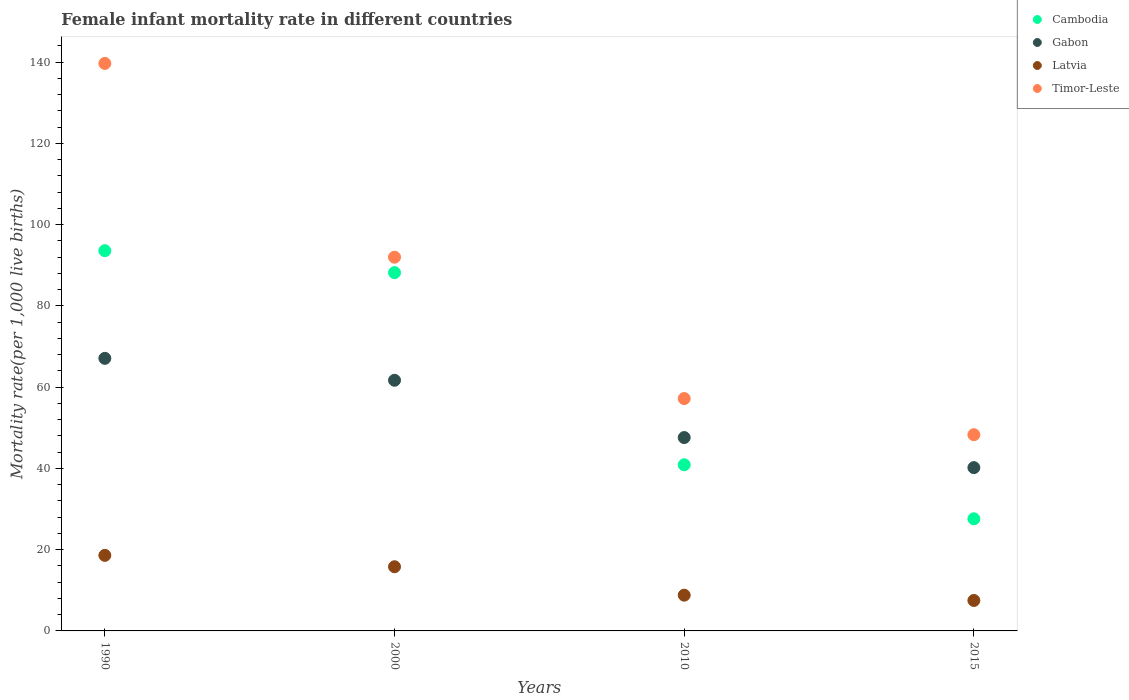How many different coloured dotlines are there?
Your answer should be compact. 4. Is the number of dotlines equal to the number of legend labels?
Offer a very short reply. Yes. What is the female infant mortality rate in Gabon in 1990?
Provide a succinct answer. 67.1. Across all years, what is the maximum female infant mortality rate in Gabon?
Provide a succinct answer. 67.1. Across all years, what is the minimum female infant mortality rate in Timor-Leste?
Offer a very short reply. 48.3. In which year was the female infant mortality rate in Gabon minimum?
Offer a terse response. 2015. What is the total female infant mortality rate in Gabon in the graph?
Make the answer very short. 216.6. What is the difference between the female infant mortality rate in Timor-Leste in 1990 and that in 2015?
Give a very brief answer. 91.4. What is the difference between the female infant mortality rate in Gabon in 2015 and the female infant mortality rate in Timor-Leste in 2010?
Your answer should be very brief. -17. What is the average female infant mortality rate in Gabon per year?
Offer a terse response. 54.15. In the year 2000, what is the difference between the female infant mortality rate in Gabon and female infant mortality rate in Timor-Leste?
Make the answer very short. -30.3. What is the ratio of the female infant mortality rate in Timor-Leste in 2010 to that in 2015?
Keep it short and to the point. 1.18. Is the female infant mortality rate in Gabon in 1990 less than that in 2015?
Offer a terse response. No. Is the difference between the female infant mortality rate in Gabon in 1990 and 2015 greater than the difference between the female infant mortality rate in Timor-Leste in 1990 and 2015?
Keep it short and to the point. No. What is the difference between the highest and the second highest female infant mortality rate in Gabon?
Offer a terse response. 5.4. What is the difference between the highest and the lowest female infant mortality rate in Timor-Leste?
Your answer should be very brief. 91.4. In how many years, is the female infant mortality rate in Cambodia greater than the average female infant mortality rate in Cambodia taken over all years?
Offer a very short reply. 2. Is it the case that in every year, the sum of the female infant mortality rate in Cambodia and female infant mortality rate in Latvia  is greater than the female infant mortality rate in Timor-Leste?
Ensure brevity in your answer.  No. Is the female infant mortality rate in Timor-Leste strictly greater than the female infant mortality rate in Cambodia over the years?
Offer a terse response. Yes. Is the female infant mortality rate in Gabon strictly less than the female infant mortality rate in Timor-Leste over the years?
Offer a terse response. Yes. What is the difference between two consecutive major ticks on the Y-axis?
Make the answer very short. 20. Does the graph contain any zero values?
Your answer should be very brief. No. Does the graph contain grids?
Your answer should be very brief. No. Where does the legend appear in the graph?
Offer a terse response. Top right. What is the title of the graph?
Provide a succinct answer. Female infant mortality rate in different countries. What is the label or title of the Y-axis?
Give a very brief answer. Mortality rate(per 1,0 live births). What is the Mortality rate(per 1,000 live births) of Cambodia in 1990?
Keep it short and to the point. 93.6. What is the Mortality rate(per 1,000 live births) in Gabon in 1990?
Keep it short and to the point. 67.1. What is the Mortality rate(per 1,000 live births) in Timor-Leste in 1990?
Give a very brief answer. 139.7. What is the Mortality rate(per 1,000 live births) of Cambodia in 2000?
Give a very brief answer. 88.2. What is the Mortality rate(per 1,000 live births) in Gabon in 2000?
Your answer should be very brief. 61.7. What is the Mortality rate(per 1,000 live births) in Timor-Leste in 2000?
Provide a succinct answer. 92. What is the Mortality rate(per 1,000 live births) of Cambodia in 2010?
Give a very brief answer. 40.9. What is the Mortality rate(per 1,000 live births) of Gabon in 2010?
Your response must be concise. 47.6. What is the Mortality rate(per 1,000 live births) of Latvia in 2010?
Your answer should be very brief. 8.8. What is the Mortality rate(per 1,000 live births) in Timor-Leste in 2010?
Offer a terse response. 57.2. What is the Mortality rate(per 1,000 live births) of Cambodia in 2015?
Offer a terse response. 27.6. What is the Mortality rate(per 1,000 live births) of Gabon in 2015?
Provide a succinct answer. 40.2. What is the Mortality rate(per 1,000 live births) of Latvia in 2015?
Give a very brief answer. 7.5. What is the Mortality rate(per 1,000 live births) of Timor-Leste in 2015?
Provide a succinct answer. 48.3. Across all years, what is the maximum Mortality rate(per 1,000 live births) in Cambodia?
Your response must be concise. 93.6. Across all years, what is the maximum Mortality rate(per 1,000 live births) in Gabon?
Offer a terse response. 67.1. Across all years, what is the maximum Mortality rate(per 1,000 live births) in Timor-Leste?
Your response must be concise. 139.7. Across all years, what is the minimum Mortality rate(per 1,000 live births) in Cambodia?
Keep it short and to the point. 27.6. Across all years, what is the minimum Mortality rate(per 1,000 live births) of Gabon?
Provide a short and direct response. 40.2. Across all years, what is the minimum Mortality rate(per 1,000 live births) in Latvia?
Your response must be concise. 7.5. Across all years, what is the minimum Mortality rate(per 1,000 live births) of Timor-Leste?
Your answer should be very brief. 48.3. What is the total Mortality rate(per 1,000 live births) in Cambodia in the graph?
Your response must be concise. 250.3. What is the total Mortality rate(per 1,000 live births) in Gabon in the graph?
Your answer should be very brief. 216.6. What is the total Mortality rate(per 1,000 live births) in Latvia in the graph?
Make the answer very short. 50.7. What is the total Mortality rate(per 1,000 live births) in Timor-Leste in the graph?
Offer a very short reply. 337.2. What is the difference between the Mortality rate(per 1,000 live births) of Gabon in 1990 and that in 2000?
Your response must be concise. 5.4. What is the difference between the Mortality rate(per 1,000 live births) in Latvia in 1990 and that in 2000?
Offer a terse response. 2.8. What is the difference between the Mortality rate(per 1,000 live births) in Timor-Leste in 1990 and that in 2000?
Make the answer very short. 47.7. What is the difference between the Mortality rate(per 1,000 live births) in Cambodia in 1990 and that in 2010?
Offer a very short reply. 52.7. What is the difference between the Mortality rate(per 1,000 live births) in Gabon in 1990 and that in 2010?
Make the answer very short. 19.5. What is the difference between the Mortality rate(per 1,000 live births) of Timor-Leste in 1990 and that in 2010?
Your response must be concise. 82.5. What is the difference between the Mortality rate(per 1,000 live births) in Cambodia in 1990 and that in 2015?
Offer a terse response. 66. What is the difference between the Mortality rate(per 1,000 live births) of Gabon in 1990 and that in 2015?
Your answer should be compact. 26.9. What is the difference between the Mortality rate(per 1,000 live births) in Timor-Leste in 1990 and that in 2015?
Make the answer very short. 91.4. What is the difference between the Mortality rate(per 1,000 live births) of Cambodia in 2000 and that in 2010?
Your answer should be very brief. 47.3. What is the difference between the Mortality rate(per 1,000 live births) of Gabon in 2000 and that in 2010?
Ensure brevity in your answer.  14.1. What is the difference between the Mortality rate(per 1,000 live births) in Latvia in 2000 and that in 2010?
Provide a succinct answer. 7. What is the difference between the Mortality rate(per 1,000 live births) in Timor-Leste in 2000 and that in 2010?
Your answer should be very brief. 34.8. What is the difference between the Mortality rate(per 1,000 live births) of Cambodia in 2000 and that in 2015?
Offer a terse response. 60.6. What is the difference between the Mortality rate(per 1,000 live births) of Timor-Leste in 2000 and that in 2015?
Provide a short and direct response. 43.7. What is the difference between the Mortality rate(per 1,000 live births) in Gabon in 2010 and that in 2015?
Your answer should be very brief. 7.4. What is the difference between the Mortality rate(per 1,000 live births) of Timor-Leste in 2010 and that in 2015?
Offer a very short reply. 8.9. What is the difference between the Mortality rate(per 1,000 live births) in Cambodia in 1990 and the Mortality rate(per 1,000 live births) in Gabon in 2000?
Make the answer very short. 31.9. What is the difference between the Mortality rate(per 1,000 live births) of Cambodia in 1990 and the Mortality rate(per 1,000 live births) of Latvia in 2000?
Ensure brevity in your answer.  77.8. What is the difference between the Mortality rate(per 1,000 live births) of Gabon in 1990 and the Mortality rate(per 1,000 live births) of Latvia in 2000?
Provide a succinct answer. 51.3. What is the difference between the Mortality rate(per 1,000 live births) of Gabon in 1990 and the Mortality rate(per 1,000 live births) of Timor-Leste in 2000?
Offer a terse response. -24.9. What is the difference between the Mortality rate(per 1,000 live births) of Latvia in 1990 and the Mortality rate(per 1,000 live births) of Timor-Leste in 2000?
Provide a succinct answer. -73.4. What is the difference between the Mortality rate(per 1,000 live births) of Cambodia in 1990 and the Mortality rate(per 1,000 live births) of Gabon in 2010?
Give a very brief answer. 46. What is the difference between the Mortality rate(per 1,000 live births) of Cambodia in 1990 and the Mortality rate(per 1,000 live births) of Latvia in 2010?
Offer a very short reply. 84.8. What is the difference between the Mortality rate(per 1,000 live births) in Cambodia in 1990 and the Mortality rate(per 1,000 live births) in Timor-Leste in 2010?
Ensure brevity in your answer.  36.4. What is the difference between the Mortality rate(per 1,000 live births) in Gabon in 1990 and the Mortality rate(per 1,000 live births) in Latvia in 2010?
Make the answer very short. 58.3. What is the difference between the Mortality rate(per 1,000 live births) of Gabon in 1990 and the Mortality rate(per 1,000 live births) of Timor-Leste in 2010?
Keep it short and to the point. 9.9. What is the difference between the Mortality rate(per 1,000 live births) of Latvia in 1990 and the Mortality rate(per 1,000 live births) of Timor-Leste in 2010?
Ensure brevity in your answer.  -38.6. What is the difference between the Mortality rate(per 1,000 live births) of Cambodia in 1990 and the Mortality rate(per 1,000 live births) of Gabon in 2015?
Make the answer very short. 53.4. What is the difference between the Mortality rate(per 1,000 live births) in Cambodia in 1990 and the Mortality rate(per 1,000 live births) in Latvia in 2015?
Offer a very short reply. 86.1. What is the difference between the Mortality rate(per 1,000 live births) of Cambodia in 1990 and the Mortality rate(per 1,000 live births) of Timor-Leste in 2015?
Offer a terse response. 45.3. What is the difference between the Mortality rate(per 1,000 live births) in Gabon in 1990 and the Mortality rate(per 1,000 live births) in Latvia in 2015?
Make the answer very short. 59.6. What is the difference between the Mortality rate(per 1,000 live births) of Gabon in 1990 and the Mortality rate(per 1,000 live births) of Timor-Leste in 2015?
Offer a terse response. 18.8. What is the difference between the Mortality rate(per 1,000 live births) of Latvia in 1990 and the Mortality rate(per 1,000 live births) of Timor-Leste in 2015?
Offer a terse response. -29.7. What is the difference between the Mortality rate(per 1,000 live births) of Cambodia in 2000 and the Mortality rate(per 1,000 live births) of Gabon in 2010?
Keep it short and to the point. 40.6. What is the difference between the Mortality rate(per 1,000 live births) of Cambodia in 2000 and the Mortality rate(per 1,000 live births) of Latvia in 2010?
Provide a succinct answer. 79.4. What is the difference between the Mortality rate(per 1,000 live births) of Cambodia in 2000 and the Mortality rate(per 1,000 live births) of Timor-Leste in 2010?
Your answer should be compact. 31. What is the difference between the Mortality rate(per 1,000 live births) of Gabon in 2000 and the Mortality rate(per 1,000 live births) of Latvia in 2010?
Ensure brevity in your answer.  52.9. What is the difference between the Mortality rate(per 1,000 live births) of Latvia in 2000 and the Mortality rate(per 1,000 live births) of Timor-Leste in 2010?
Give a very brief answer. -41.4. What is the difference between the Mortality rate(per 1,000 live births) of Cambodia in 2000 and the Mortality rate(per 1,000 live births) of Latvia in 2015?
Your response must be concise. 80.7. What is the difference between the Mortality rate(per 1,000 live births) of Cambodia in 2000 and the Mortality rate(per 1,000 live births) of Timor-Leste in 2015?
Ensure brevity in your answer.  39.9. What is the difference between the Mortality rate(per 1,000 live births) of Gabon in 2000 and the Mortality rate(per 1,000 live births) of Latvia in 2015?
Give a very brief answer. 54.2. What is the difference between the Mortality rate(per 1,000 live births) of Latvia in 2000 and the Mortality rate(per 1,000 live births) of Timor-Leste in 2015?
Your response must be concise. -32.5. What is the difference between the Mortality rate(per 1,000 live births) of Cambodia in 2010 and the Mortality rate(per 1,000 live births) of Latvia in 2015?
Your answer should be very brief. 33.4. What is the difference between the Mortality rate(per 1,000 live births) in Gabon in 2010 and the Mortality rate(per 1,000 live births) in Latvia in 2015?
Your answer should be compact. 40.1. What is the difference between the Mortality rate(per 1,000 live births) in Gabon in 2010 and the Mortality rate(per 1,000 live births) in Timor-Leste in 2015?
Provide a succinct answer. -0.7. What is the difference between the Mortality rate(per 1,000 live births) in Latvia in 2010 and the Mortality rate(per 1,000 live births) in Timor-Leste in 2015?
Make the answer very short. -39.5. What is the average Mortality rate(per 1,000 live births) in Cambodia per year?
Your response must be concise. 62.58. What is the average Mortality rate(per 1,000 live births) in Gabon per year?
Your answer should be compact. 54.15. What is the average Mortality rate(per 1,000 live births) in Latvia per year?
Your answer should be compact. 12.68. What is the average Mortality rate(per 1,000 live births) in Timor-Leste per year?
Your answer should be compact. 84.3. In the year 1990, what is the difference between the Mortality rate(per 1,000 live births) in Cambodia and Mortality rate(per 1,000 live births) in Gabon?
Your answer should be compact. 26.5. In the year 1990, what is the difference between the Mortality rate(per 1,000 live births) of Cambodia and Mortality rate(per 1,000 live births) of Latvia?
Make the answer very short. 75. In the year 1990, what is the difference between the Mortality rate(per 1,000 live births) in Cambodia and Mortality rate(per 1,000 live births) in Timor-Leste?
Ensure brevity in your answer.  -46.1. In the year 1990, what is the difference between the Mortality rate(per 1,000 live births) of Gabon and Mortality rate(per 1,000 live births) of Latvia?
Make the answer very short. 48.5. In the year 1990, what is the difference between the Mortality rate(per 1,000 live births) in Gabon and Mortality rate(per 1,000 live births) in Timor-Leste?
Your response must be concise. -72.6. In the year 1990, what is the difference between the Mortality rate(per 1,000 live births) in Latvia and Mortality rate(per 1,000 live births) in Timor-Leste?
Offer a terse response. -121.1. In the year 2000, what is the difference between the Mortality rate(per 1,000 live births) of Cambodia and Mortality rate(per 1,000 live births) of Gabon?
Ensure brevity in your answer.  26.5. In the year 2000, what is the difference between the Mortality rate(per 1,000 live births) of Cambodia and Mortality rate(per 1,000 live births) of Latvia?
Make the answer very short. 72.4. In the year 2000, what is the difference between the Mortality rate(per 1,000 live births) in Cambodia and Mortality rate(per 1,000 live births) in Timor-Leste?
Offer a very short reply. -3.8. In the year 2000, what is the difference between the Mortality rate(per 1,000 live births) of Gabon and Mortality rate(per 1,000 live births) of Latvia?
Your answer should be very brief. 45.9. In the year 2000, what is the difference between the Mortality rate(per 1,000 live births) of Gabon and Mortality rate(per 1,000 live births) of Timor-Leste?
Ensure brevity in your answer.  -30.3. In the year 2000, what is the difference between the Mortality rate(per 1,000 live births) of Latvia and Mortality rate(per 1,000 live births) of Timor-Leste?
Make the answer very short. -76.2. In the year 2010, what is the difference between the Mortality rate(per 1,000 live births) in Cambodia and Mortality rate(per 1,000 live births) in Latvia?
Keep it short and to the point. 32.1. In the year 2010, what is the difference between the Mortality rate(per 1,000 live births) of Cambodia and Mortality rate(per 1,000 live births) of Timor-Leste?
Provide a succinct answer. -16.3. In the year 2010, what is the difference between the Mortality rate(per 1,000 live births) of Gabon and Mortality rate(per 1,000 live births) of Latvia?
Give a very brief answer. 38.8. In the year 2010, what is the difference between the Mortality rate(per 1,000 live births) in Latvia and Mortality rate(per 1,000 live births) in Timor-Leste?
Make the answer very short. -48.4. In the year 2015, what is the difference between the Mortality rate(per 1,000 live births) in Cambodia and Mortality rate(per 1,000 live births) in Gabon?
Make the answer very short. -12.6. In the year 2015, what is the difference between the Mortality rate(per 1,000 live births) in Cambodia and Mortality rate(per 1,000 live births) in Latvia?
Provide a succinct answer. 20.1. In the year 2015, what is the difference between the Mortality rate(per 1,000 live births) in Cambodia and Mortality rate(per 1,000 live births) in Timor-Leste?
Keep it short and to the point. -20.7. In the year 2015, what is the difference between the Mortality rate(per 1,000 live births) of Gabon and Mortality rate(per 1,000 live births) of Latvia?
Your response must be concise. 32.7. In the year 2015, what is the difference between the Mortality rate(per 1,000 live births) of Gabon and Mortality rate(per 1,000 live births) of Timor-Leste?
Provide a short and direct response. -8.1. In the year 2015, what is the difference between the Mortality rate(per 1,000 live births) of Latvia and Mortality rate(per 1,000 live births) of Timor-Leste?
Your response must be concise. -40.8. What is the ratio of the Mortality rate(per 1,000 live births) of Cambodia in 1990 to that in 2000?
Provide a succinct answer. 1.06. What is the ratio of the Mortality rate(per 1,000 live births) in Gabon in 1990 to that in 2000?
Provide a succinct answer. 1.09. What is the ratio of the Mortality rate(per 1,000 live births) of Latvia in 1990 to that in 2000?
Offer a very short reply. 1.18. What is the ratio of the Mortality rate(per 1,000 live births) in Timor-Leste in 1990 to that in 2000?
Your answer should be very brief. 1.52. What is the ratio of the Mortality rate(per 1,000 live births) of Cambodia in 1990 to that in 2010?
Your response must be concise. 2.29. What is the ratio of the Mortality rate(per 1,000 live births) in Gabon in 1990 to that in 2010?
Your answer should be very brief. 1.41. What is the ratio of the Mortality rate(per 1,000 live births) in Latvia in 1990 to that in 2010?
Make the answer very short. 2.11. What is the ratio of the Mortality rate(per 1,000 live births) of Timor-Leste in 1990 to that in 2010?
Offer a terse response. 2.44. What is the ratio of the Mortality rate(per 1,000 live births) in Cambodia in 1990 to that in 2015?
Give a very brief answer. 3.39. What is the ratio of the Mortality rate(per 1,000 live births) in Gabon in 1990 to that in 2015?
Offer a terse response. 1.67. What is the ratio of the Mortality rate(per 1,000 live births) of Latvia in 1990 to that in 2015?
Give a very brief answer. 2.48. What is the ratio of the Mortality rate(per 1,000 live births) of Timor-Leste in 1990 to that in 2015?
Provide a short and direct response. 2.89. What is the ratio of the Mortality rate(per 1,000 live births) in Cambodia in 2000 to that in 2010?
Your response must be concise. 2.16. What is the ratio of the Mortality rate(per 1,000 live births) in Gabon in 2000 to that in 2010?
Your response must be concise. 1.3. What is the ratio of the Mortality rate(per 1,000 live births) in Latvia in 2000 to that in 2010?
Make the answer very short. 1.8. What is the ratio of the Mortality rate(per 1,000 live births) in Timor-Leste in 2000 to that in 2010?
Offer a very short reply. 1.61. What is the ratio of the Mortality rate(per 1,000 live births) of Cambodia in 2000 to that in 2015?
Offer a terse response. 3.2. What is the ratio of the Mortality rate(per 1,000 live births) in Gabon in 2000 to that in 2015?
Give a very brief answer. 1.53. What is the ratio of the Mortality rate(per 1,000 live births) in Latvia in 2000 to that in 2015?
Offer a very short reply. 2.11. What is the ratio of the Mortality rate(per 1,000 live births) of Timor-Leste in 2000 to that in 2015?
Ensure brevity in your answer.  1.9. What is the ratio of the Mortality rate(per 1,000 live births) of Cambodia in 2010 to that in 2015?
Offer a very short reply. 1.48. What is the ratio of the Mortality rate(per 1,000 live births) of Gabon in 2010 to that in 2015?
Your answer should be compact. 1.18. What is the ratio of the Mortality rate(per 1,000 live births) of Latvia in 2010 to that in 2015?
Provide a short and direct response. 1.17. What is the ratio of the Mortality rate(per 1,000 live births) in Timor-Leste in 2010 to that in 2015?
Give a very brief answer. 1.18. What is the difference between the highest and the second highest Mortality rate(per 1,000 live births) in Timor-Leste?
Keep it short and to the point. 47.7. What is the difference between the highest and the lowest Mortality rate(per 1,000 live births) of Cambodia?
Ensure brevity in your answer.  66. What is the difference between the highest and the lowest Mortality rate(per 1,000 live births) of Gabon?
Provide a short and direct response. 26.9. What is the difference between the highest and the lowest Mortality rate(per 1,000 live births) of Latvia?
Provide a short and direct response. 11.1. What is the difference between the highest and the lowest Mortality rate(per 1,000 live births) of Timor-Leste?
Offer a terse response. 91.4. 